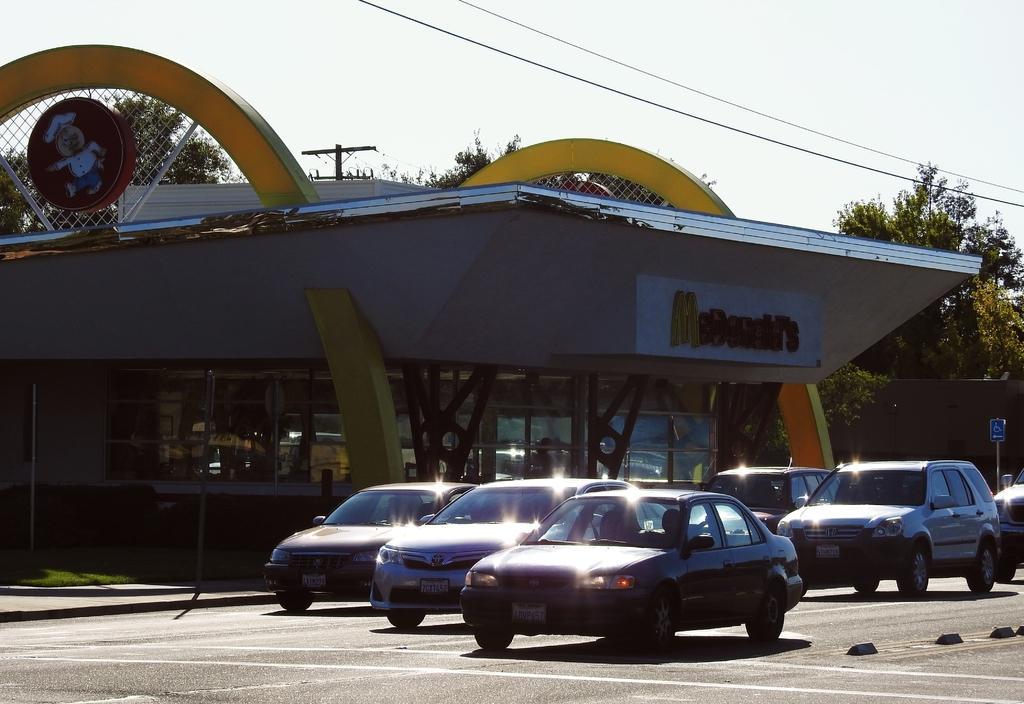Please provide a concise description of this image. In this image we can see building, name board, mesh, electric pole, electric cables, sign board, motor vehicles on the road and ground. 